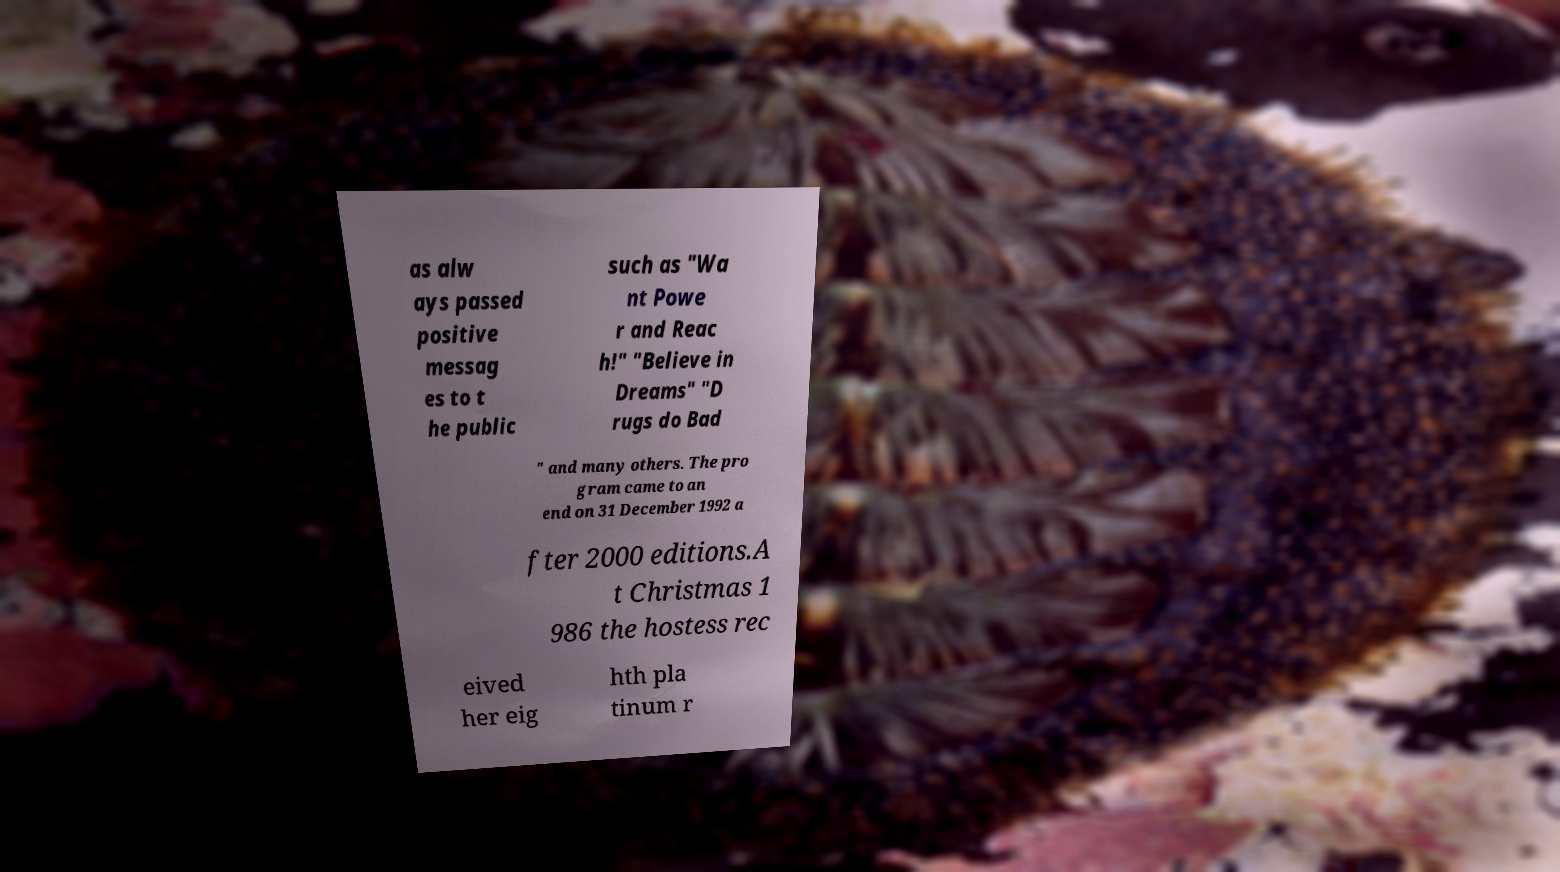There's text embedded in this image that I need extracted. Can you transcribe it verbatim? as alw ays passed positive messag es to t he public such as "Wa nt Powe r and Reac h!" "Believe in Dreams" "D rugs do Bad " and many others. The pro gram came to an end on 31 December 1992 a fter 2000 editions.A t Christmas 1 986 the hostess rec eived her eig hth pla tinum r 